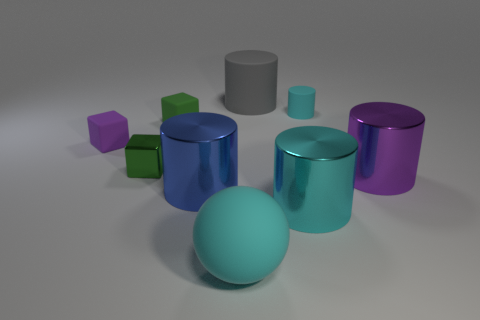How many objects are there in this image, and can you sort them by color? There are ten objects in the image. Sorting them by color, starting with the colors that have the most objects, we have: three blue objects, which include two cylinders and one cube; two green cubes; two gray objects, a sphere and a cylinder; two purple objects, a cylinder and a cube; and one teal cylinder. 